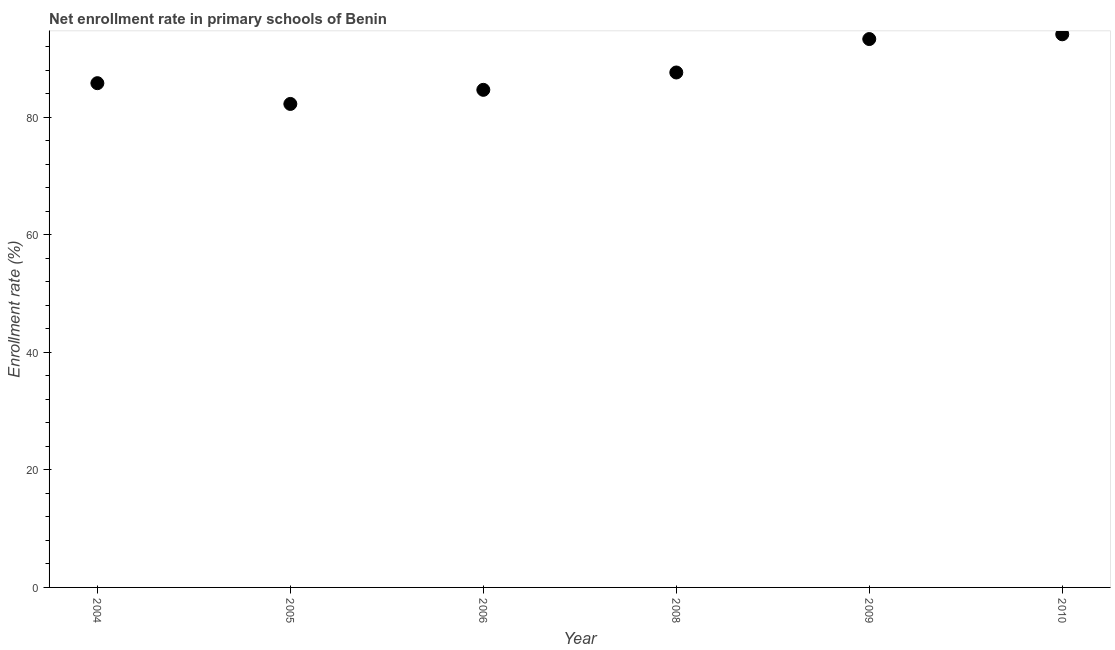What is the net enrollment rate in primary schools in 2006?
Make the answer very short. 84.67. Across all years, what is the maximum net enrollment rate in primary schools?
Your answer should be compact. 94.12. Across all years, what is the minimum net enrollment rate in primary schools?
Ensure brevity in your answer.  82.27. In which year was the net enrollment rate in primary schools minimum?
Your answer should be very brief. 2005. What is the sum of the net enrollment rate in primary schools?
Your answer should be very brief. 527.81. What is the difference between the net enrollment rate in primary schools in 2008 and 2010?
Offer a terse response. -6.5. What is the average net enrollment rate in primary schools per year?
Provide a short and direct response. 87.97. What is the median net enrollment rate in primary schools?
Provide a succinct answer. 86.71. In how many years, is the net enrollment rate in primary schools greater than 48 %?
Your response must be concise. 6. What is the ratio of the net enrollment rate in primary schools in 2006 to that in 2010?
Provide a succinct answer. 0.9. Is the difference between the net enrollment rate in primary schools in 2005 and 2009 greater than the difference between any two years?
Offer a terse response. No. What is the difference between the highest and the second highest net enrollment rate in primary schools?
Offer a terse response. 0.81. Is the sum of the net enrollment rate in primary schools in 2005 and 2008 greater than the maximum net enrollment rate in primary schools across all years?
Your answer should be compact. Yes. What is the difference between the highest and the lowest net enrollment rate in primary schools?
Your answer should be compact. 11.85. Does the net enrollment rate in primary schools monotonically increase over the years?
Offer a terse response. No. How many years are there in the graph?
Your response must be concise. 6. What is the title of the graph?
Your answer should be compact. Net enrollment rate in primary schools of Benin. What is the label or title of the Y-axis?
Ensure brevity in your answer.  Enrollment rate (%). What is the Enrollment rate (%) in 2004?
Your answer should be compact. 85.81. What is the Enrollment rate (%) in 2005?
Your response must be concise. 82.27. What is the Enrollment rate (%) in 2006?
Make the answer very short. 84.67. What is the Enrollment rate (%) in 2008?
Keep it short and to the point. 87.62. What is the Enrollment rate (%) in 2009?
Offer a terse response. 93.31. What is the Enrollment rate (%) in 2010?
Your response must be concise. 94.12. What is the difference between the Enrollment rate (%) in 2004 and 2005?
Make the answer very short. 3.53. What is the difference between the Enrollment rate (%) in 2004 and 2006?
Give a very brief answer. 1.13. What is the difference between the Enrollment rate (%) in 2004 and 2008?
Give a very brief answer. -1.82. What is the difference between the Enrollment rate (%) in 2004 and 2009?
Your response must be concise. -7.51. What is the difference between the Enrollment rate (%) in 2004 and 2010?
Your answer should be compact. -8.32. What is the difference between the Enrollment rate (%) in 2005 and 2006?
Provide a short and direct response. -2.4. What is the difference between the Enrollment rate (%) in 2005 and 2008?
Provide a succinct answer. -5.35. What is the difference between the Enrollment rate (%) in 2005 and 2009?
Offer a terse response. -11.04. What is the difference between the Enrollment rate (%) in 2005 and 2010?
Your answer should be compact. -11.85. What is the difference between the Enrollment rate (%) in 2006 and 2008?
Provide a succinct answer. -2.95. What is the difference between the Enrollment rate (%) in 2006 and 2009?
Ensure brevity in your answer.  -8.64. What is the difference between the Enrollment rate (%) in 2006 and 2010?
Keep it short and to the point. -9.45. What is the difference between the Enrollment rate (%) in 2008 and 2009?
Your answer should be compact. -5.69. What is the difference between the Enrollment rate (%) in 2008 and 2010?
Provide a short and direct response. -6.5. What is the difference between the Enrollment rate (%) in 2009 and 2010?
Keep it short and to the point. -0.81. What is the ratio of the Enrollment rate (%) in 2004 to that in 2005?
Provide a short and direct response. 1.04. What is the ratio of the Enrollment rate (%) in 2004 to that in 2008?
Make the answer very short. 0.98. What is the ratio of the Enrollment rate (%) in 2004 to that in 2010?
Keep it short and to the point. 0.91. What is the ratio of the Enrollment rate (%) in 2005 to that in 2006?
Your response must be concise. 0.97. What is the ratio of the Enrollment rate (%) in 2005 to that in 2008?
Keep it short and to the point. 0.94. What is the ratio of the Enrollment rate (%) in 2005 to that in 2009?
Your response must be concise. 0.88. What is the ratio of the Enrollment rate (%) in 2005 to that in 2010?
Provide a short and direct response. 0.87. What is the ratio of the Enrollment rate (%) in 2006 to that in 2008?
Your answer should be very brief. 0.97. What is the ratio of the Enrollment rate (%) in 2006 to that in 2009?
Provide a short and direct response. 0.91. What is the ratio of the Enrollment rate (%) in 2006 to that in 2010?
Your answer should be very brief. 0.9. What is the ratio of the Enrollment rate (%) in 2008 to that in 2009?
Your answer should be very brief. 0.94. What is the ratio of the Enrollment rate (%) in 2008 to that in 2010?
Offer a terse response. 0.93. What is the ratio of the Enrollment rate (%) in 2009 to that in 2010?
Your answer should be compact. 0.99. 